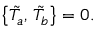<formula> <loc_0><loc_0><loc_500><loc_500>\left \{ \tilde { T } _ { a } , \, \tilde { T } _ { b } \right \} = 0 .</formula> 